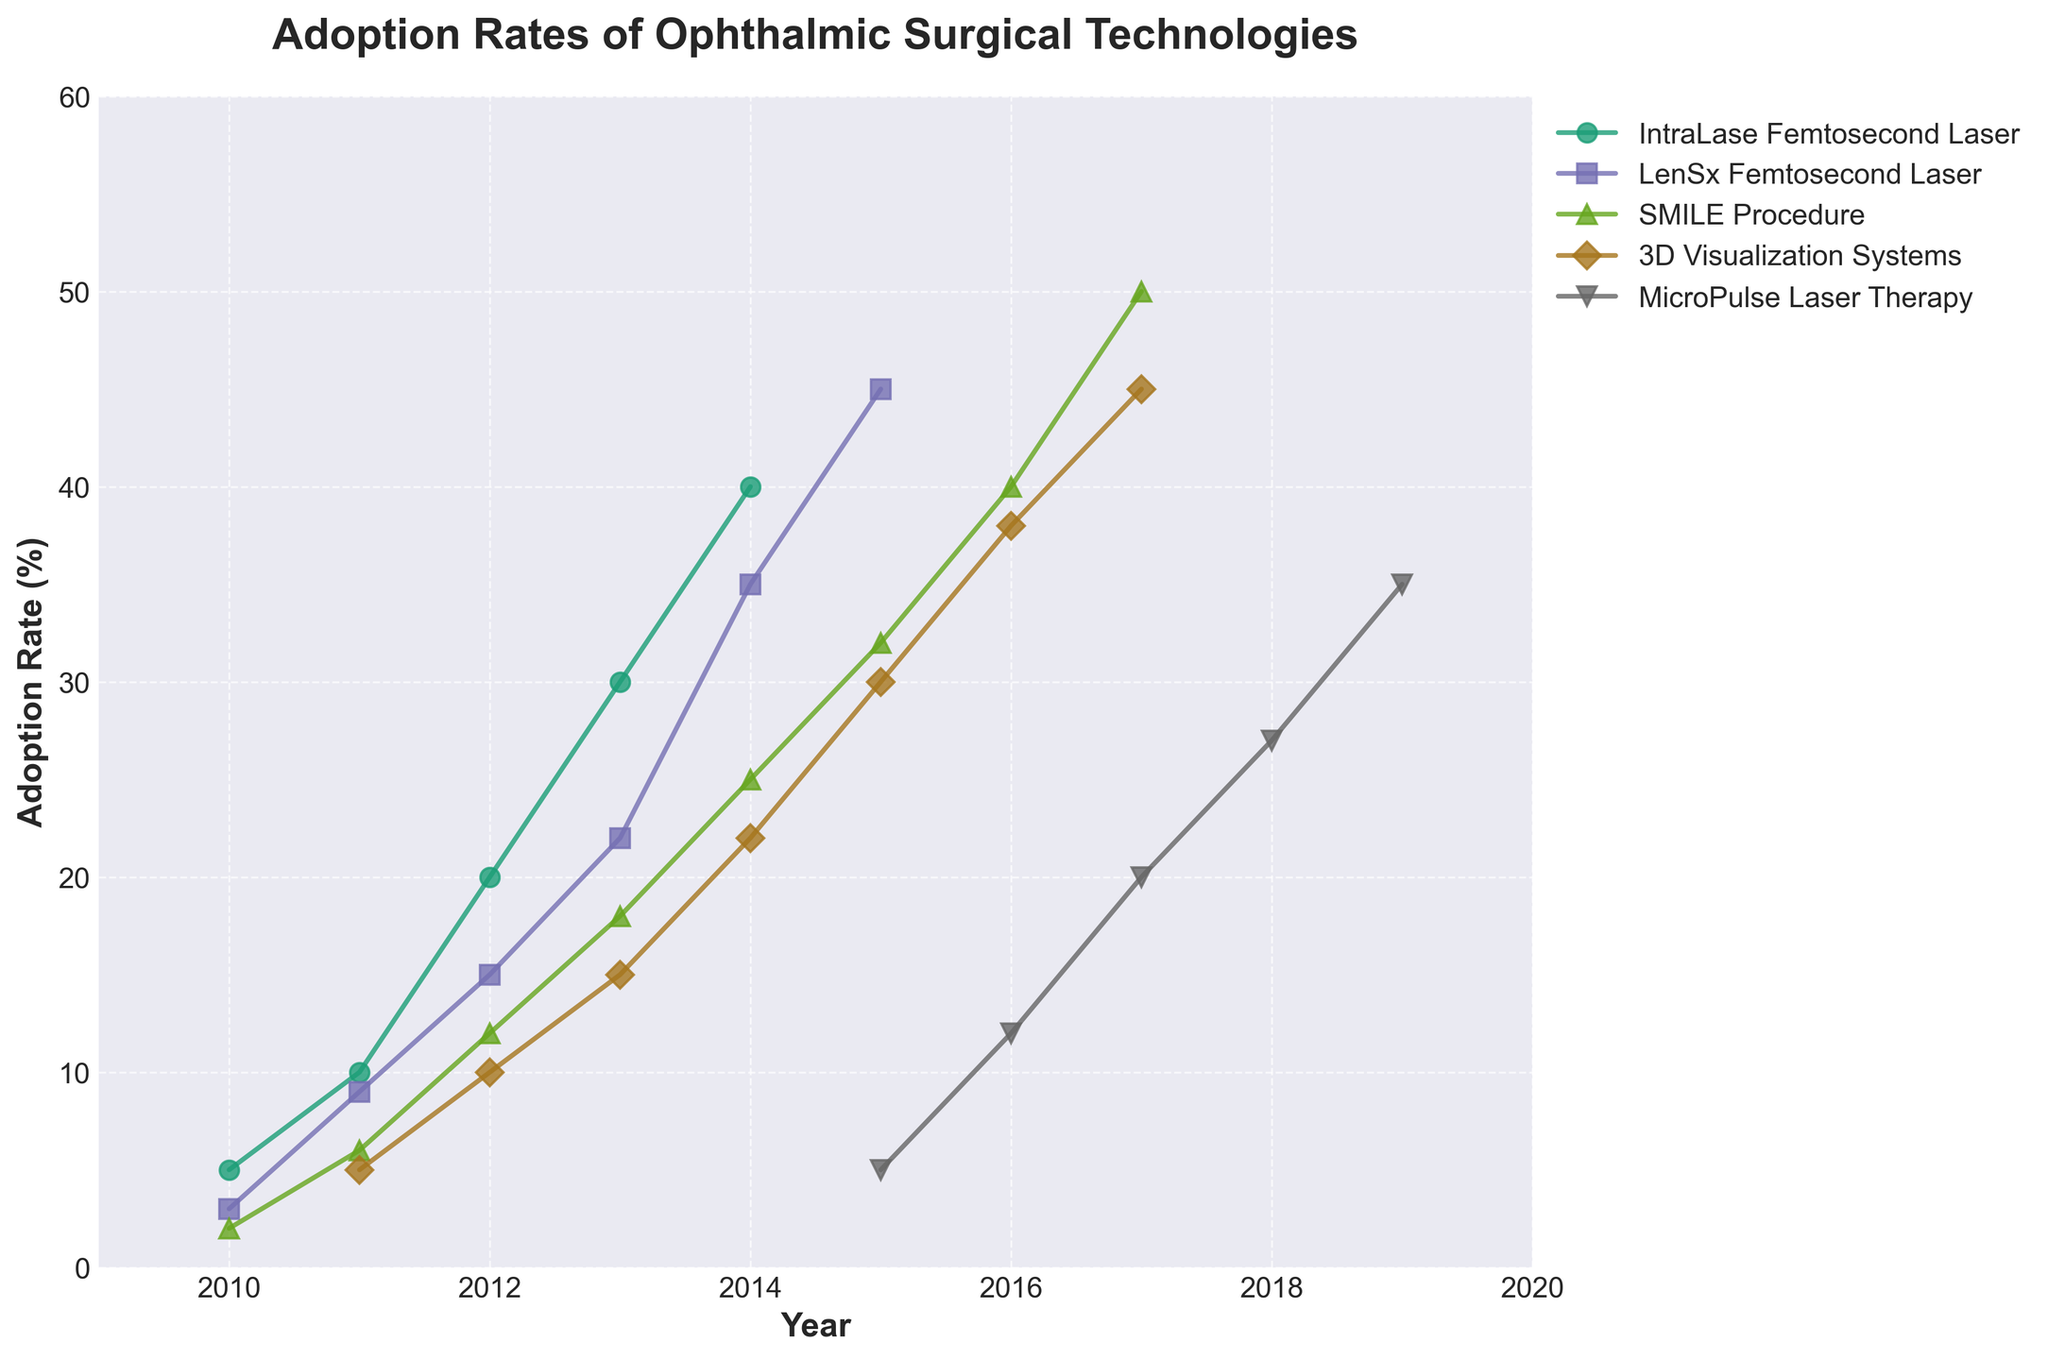What is the title of the figure? The title is displayed at the top of the figure for context identification. Based on the typical layout, it is prominently placed.
Answer: Adoption Rates of Ophthalmic Surgical Technologies What is the adoption rate percentage of the SMILE Procedure in 2017? Locate the data point corresponding to the SMILE Procedure on the year 2017 axis and read its value on the adoption rate axis.
Answer: 50% Which technology had the highest adoption rate in 2014? Compare the adoption rates for all technologies in 2014. Look for the highest value among them.
Answer: IntraLase Femtosecond Laser How did the 3D Visualization Systems' adoption rate change from 2011 to 2017? Subtract the adoption rate in 2011 from the adoption rate in 2017.
Answer: It increased by 40% (from 5% to 45%) Between 2010 and 2017, which technology showed the most consistent upward trend? Examine the slope of the adoption rate lines for each technology over the years between 2010 and 2017. Look for the one with a steady, upward trajectory without major fluctuations.
Answer: SMILE Procedure What was the increase in adoption rate of the MicroPulse Laser Therapy from 2015 to 2018? Subtract the adoption rate in 2015 from the adoption rate in 2018.
Answer: 22% (from 5% to 27%) In which year did the LenSx Femtosecond Laser have an adoption rate equal to the IntraLase Femtosecond Laser's rate? Identify a point on the plot where these two technologies intersect or closely align on the adoption rate axis.
Answer: 2014 Which technology had the lowest initial adoption rate, and what was it? Look for the technology with the smallest data point in the year 2010.
Answer: SMILE Procedure at 2% How many technologies reached an adoption rate of at least 30% by 2017? Count the number of technologies with data points at or above 30% on the adoption rate axis in the year 2017.
Answer: 4 (IntraLase Femtosecond Laser, LenSx Femtosecond Laser, SMILE Procedure, 3D Visualization Systems) 